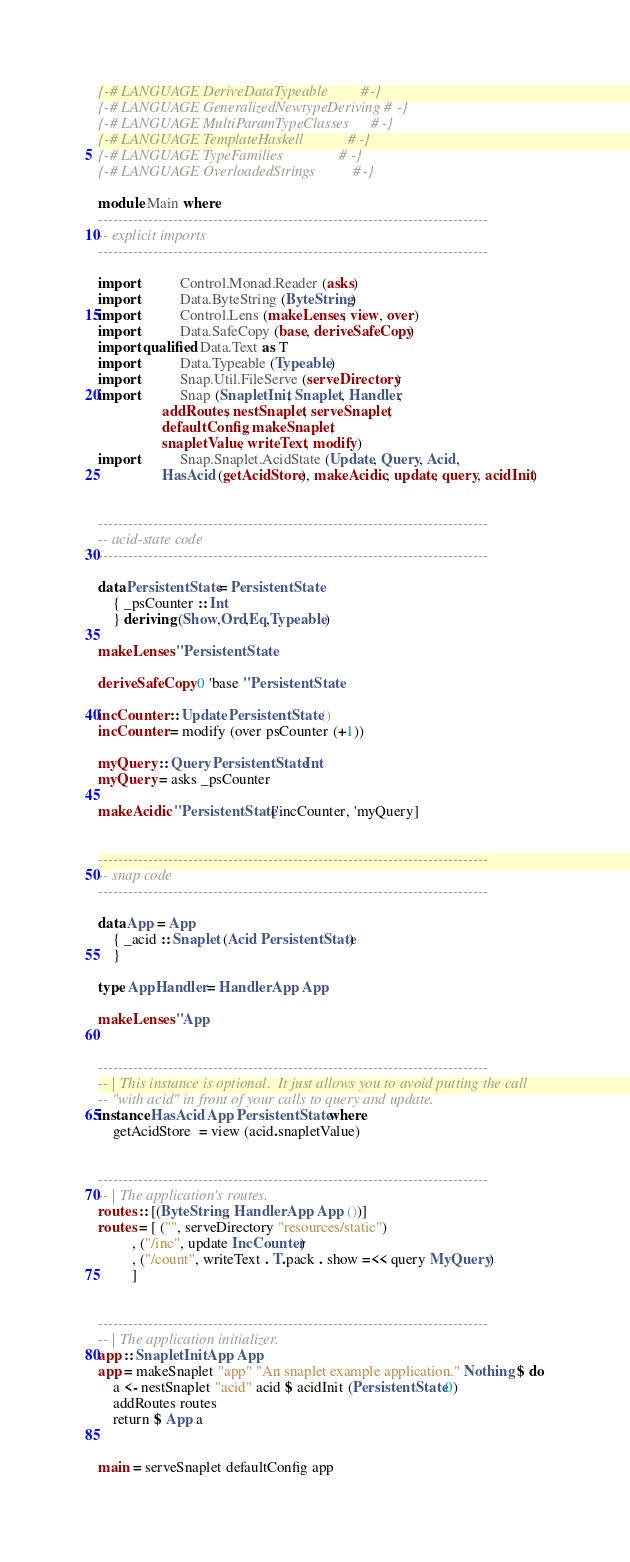<code> <loc_0><loc_0><loc_500><loc_500><_Haskell_>{-# LANGUAGE DeriveDataTypeable         #-}
{-# LANGUAGE GeneralizedNewtypeDeriving #-}
{-# LANGUAGE MultiParamTypeClasses      #-}
{-# LANGUAGE TemplateHaskell            #-}
{-# LANGUAGE TypeFamilies               #-}
{-# LANGUAGE OverloadedStrings          #-}

module Main where
------------------------------------------------------------------------------
-- explicit imports
------------------------------------------------------------------------------

import           Control.Monad.Reader (asks)
import           Data.ByteString (ByteString)
import           Control.Lens (makeLenses, view, over)
import           Data.SafeCopy (base, deriveSafeCopy)
import qualified Data.Text as T
import           Data.Typeable (Typeable)
import           Snap.Util.FileServe (serveDirectory)
import           Snap (SnapletInit, Snaplet, Handler, 
                 addRoutes, nestSnaplet, serveSnaplet,
                 defaultConfig, makeSnaplet, 
                 snapletValue, writeText, modify)
import           Snap.Snaplet.AcidState (Update, Query, Acid,
                 HasAcid (getAcidStore), makeAcidic, update, query, acidInit)


------------------------------------------------------------------------------
-- acid-state code
------------------------------------------------------------------------------

data PersistentState = PersistentState
    { _psCounter :: Int
    } deriving (Show,Ord,Eq,Typeable)

makeLenses ''PersistentState

deriveSafeCopy 0 'base ''PersistentState

incCounter :: Update PersistentState ()
incCounter = modify (over psCounter (+1))
    
myQuery :: Query PersistentState Int
myQuery = asks _psCounter

makeAcidic ''PersistentState ['incCounter, 'myQuery]


------------------------------------------------------------------------------
-- snap code
------------------------------------------------------------------------------

data App = App
    { _acid :: Snaplet (Acid PersistentState)
    }

type AppHandler = Handler App App

makeLenses ''App


------------------------------------------------------------------------------
-- | This instance is optional.  It just allows you to avoid putting the call
-- "with acid" in front of your calls to query and update.
instance HasAcid App PersistentState where
    getAcidStore  = view (acid.snapletValue)


------------------------------------------------------------------------------
-- | The application's routes.
routes :: [(ByteString, Handler App App ())]
routes = [ ("", serveDirectory "resources/static")
         , ("/inc", update IncCounter)
         , ("/count", writeText . T.pack . show =<< query MyQuery)
         ]


------------------------------------------------------------------------------
-- | The application initializer.
app :: SnapletInit App App
app = makeSnaplet "app" "An snaplet example application." Nothing $ do
    a <- nestSnaplet "acid" acid $ acidInit (PersistentState 0)
    addRoutes routes
    return $ App a


main = serveSnaplet defaultConfig app
</code> 